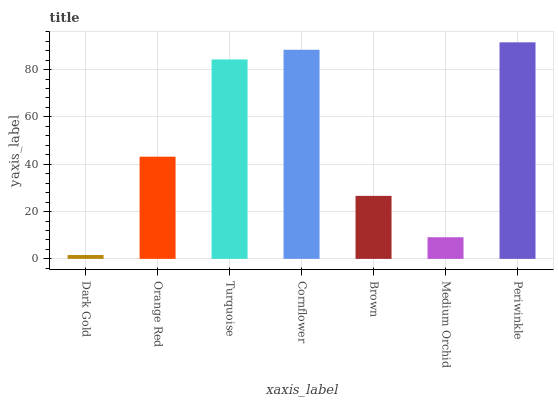Is Dark Gold the minimum?
Answer yes or no. Yes. Is Periwinkle the maximum?
Answer yes or no. Yes. Is Orange Red the minimum?
Answer yes or no. No. Is Orange Red the maximum?
Answer yes or no. No. Is Orange Red greater than Dark Gold?
Answer yes or no. Yes. Is Dark Gold less than Orange Red?
Answer yes or no. Yes. Is Dark Gold greater than Orange Red?
Answer yes or no. No. Is Orange Red less than Dark Gold?
Answer yes or no. No. Is Orange Red the high median?
Answer yes or no. Yes. Is Orange Red the low median?
Answer yes or no. Yes. Is Dark Gold the high median?
Answer yes or no. No. Is Cornflower the low median?
Answer yes or no. No. 